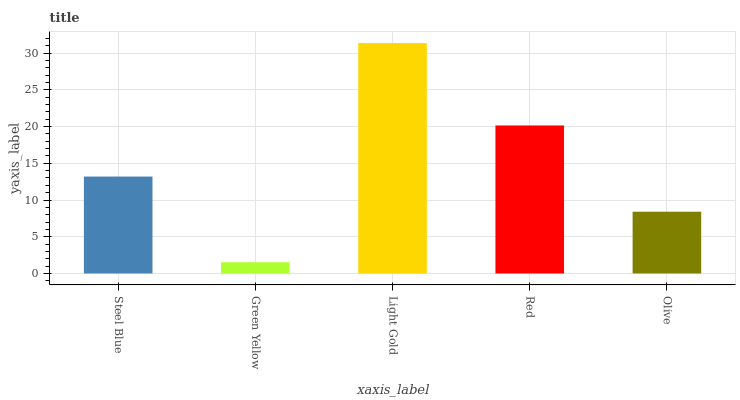Is Light Gold the minimum?
Answer yes or no. No. Is Green Yellow the maximum?
Answer yes or no. No. Is Light Gold greater than Green Yellow?
Answer yes or no. Yes. Is Green Yellow less than Light Gold?
Answer yes or no. Yes. Is Green Yellow greater than Light Gold?
Answer yes or no. No. Is Light Gold less than Green Yellow?
Answer yes or no. No. Is Steel Blue the high median?
Answer yes or no. Yes. Is Steel Blue the low median?
Answer yes or no. Yes. Is Olive the high median?
Answer yes or no. No. Is Light Gold the low median?
Answer yes or no. No. 